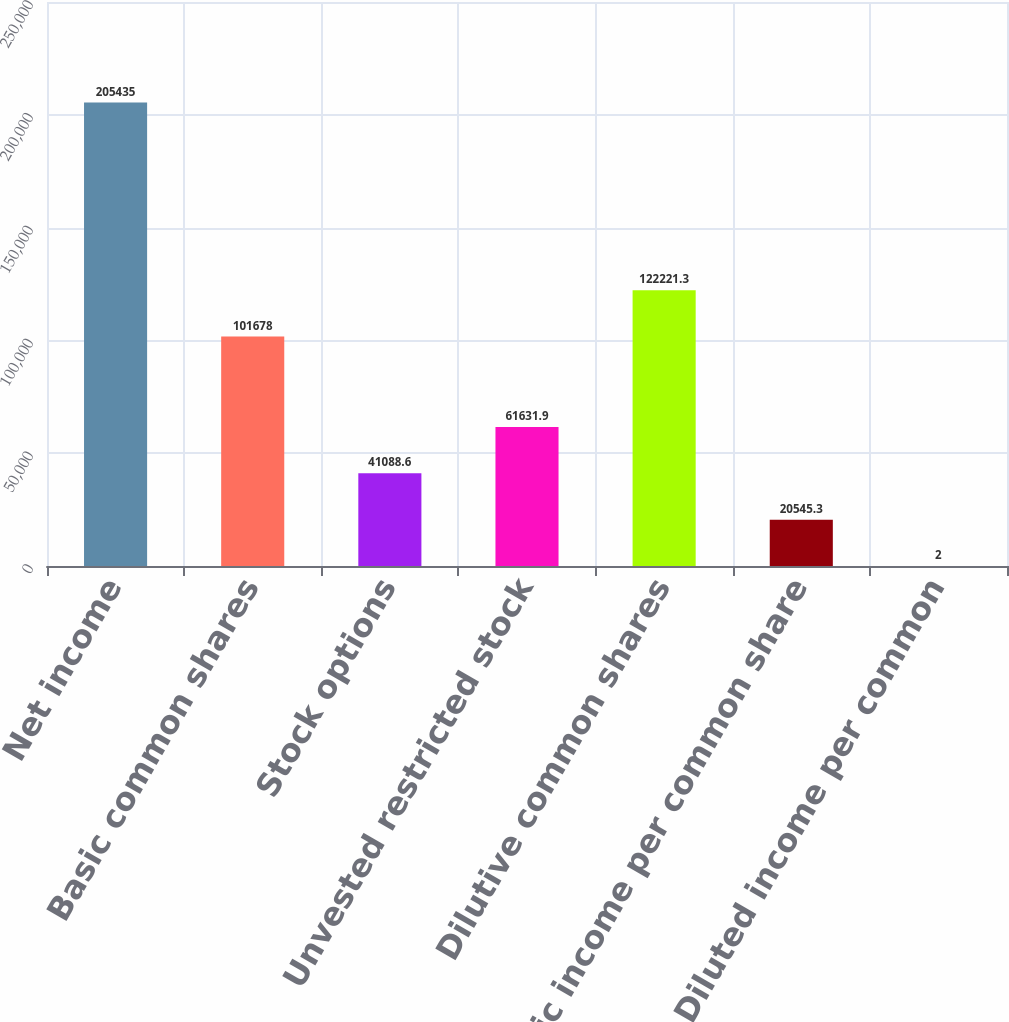Convert chart to OTSL. <chart><loc_0><loc_0><loc_500><loc_500><bar_chart><fcel>Net income<fcel>Basic common shares<fcel>Stock options<fcel>Unvested restricted stock<fcel>Dilutive common shares<fcel>Basic income per common share<fcel>Diluted income per common<nl><fcel>205435<fcel>101678<fcel>41088.6<fcel>61631.9<fcel>122221<fcel>20545.3<fcel>2<nl></chart> 